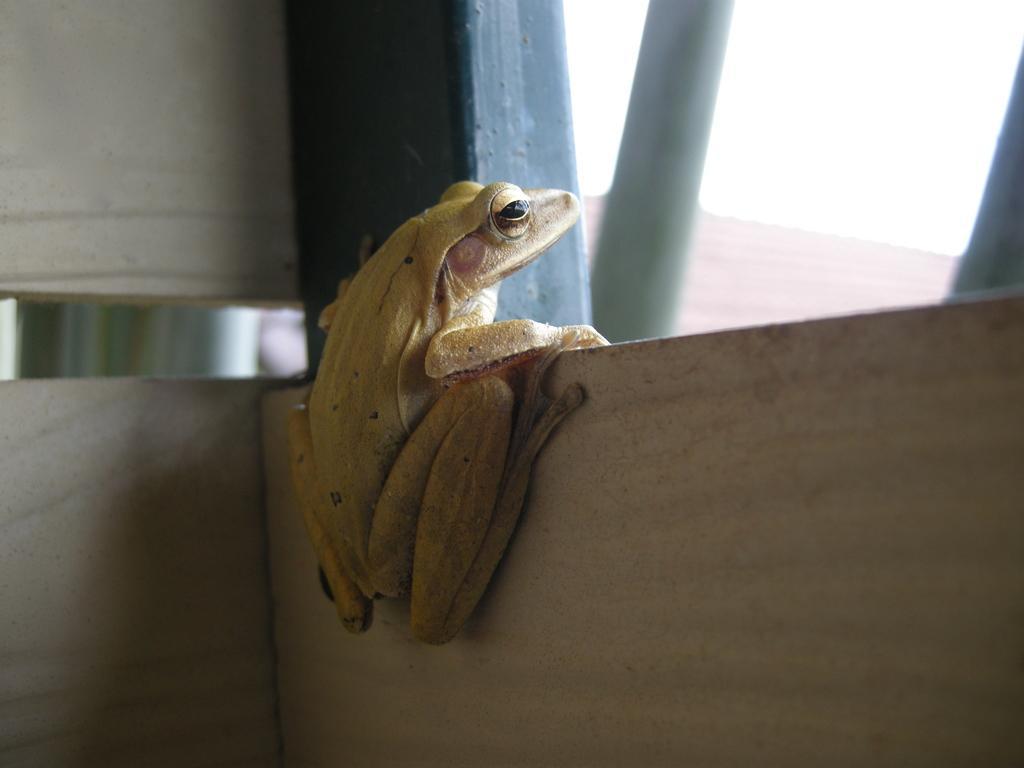Can you describe this image briefly? In this picture we can able to see a frog which is in green color, it is sitting on the wall. The frog is looking outside. The sky is very pleasant. This is rod. 